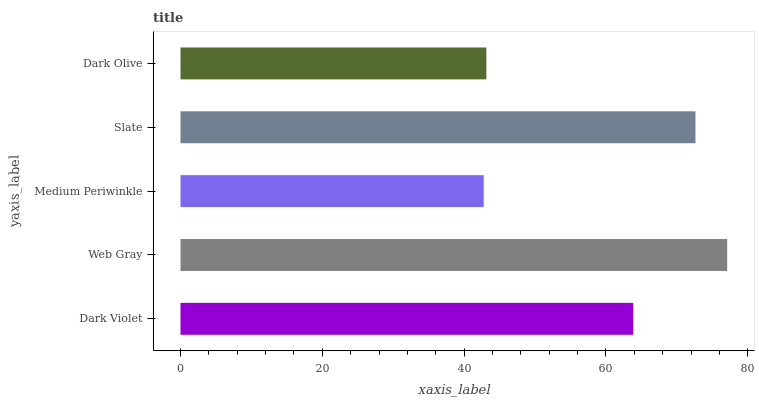Is Medium Periwinkle the minimum?
Answer yes or no. Yes. Is Web Gray the maximum?
Answer yes or no. Yes. Is Web Gray the minimum?
Answer yes or no. No. Is Medium Periwinkle the maximum?
Answer yes or no. No. Is Web Gray greater than Medium Periwinkle?
Answer yes or no. Yes. Is Medium Periwinkle less than Web Gray?
Answer yes or no. Yes. Is Medium Periwinkle greater than Web Gray?
Answer yes or no. No. Is Web Gray less than Medium Periwinkle?
Answer yes or no. No. Is Dark Violet the high median?
Answer yes or no. Yes. Is Dark Violet the low median?
Answer yes or no. Yes. Is Slate the high median?
Answer yes or no. No. Is Web Gray the low median?
Answer yes or no. No. 